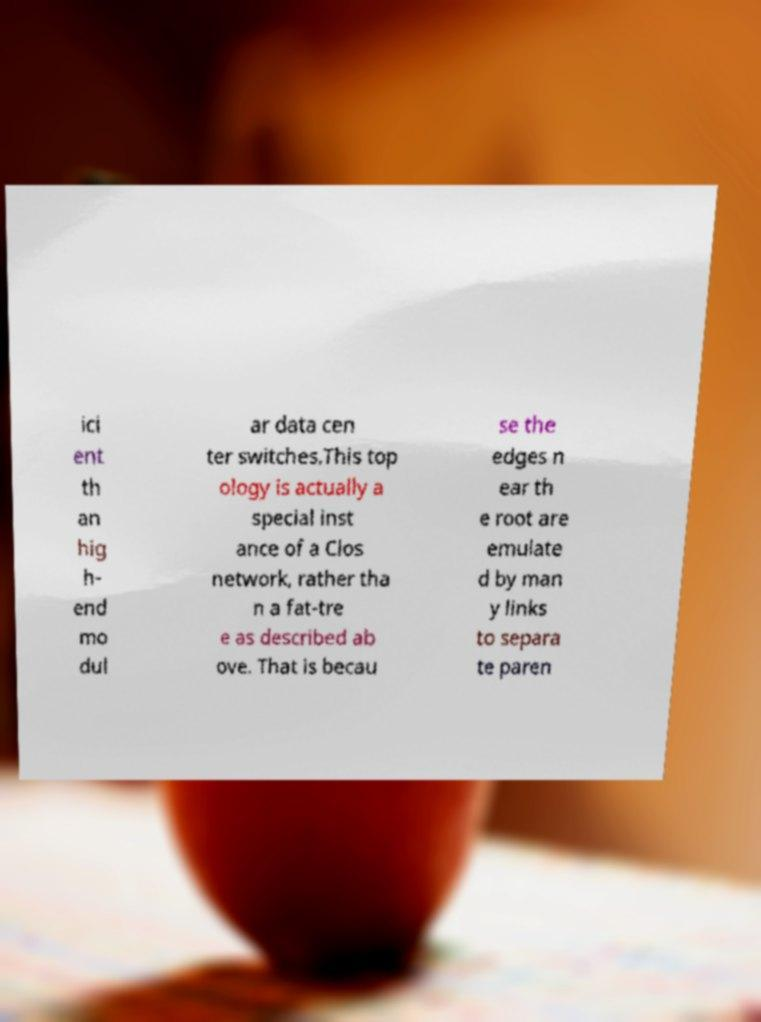What messages or text are displayed in this image? I need them in a readable, typed format. ici ent th an hig h- end mo dul ar data cen ter switches.This top ology is actually a special inst ance of a Clos network, rather tha n a fat-tre e as described ab ove. That is becau se the edges n ear th e root are emulate d by man y links to separa te paren 